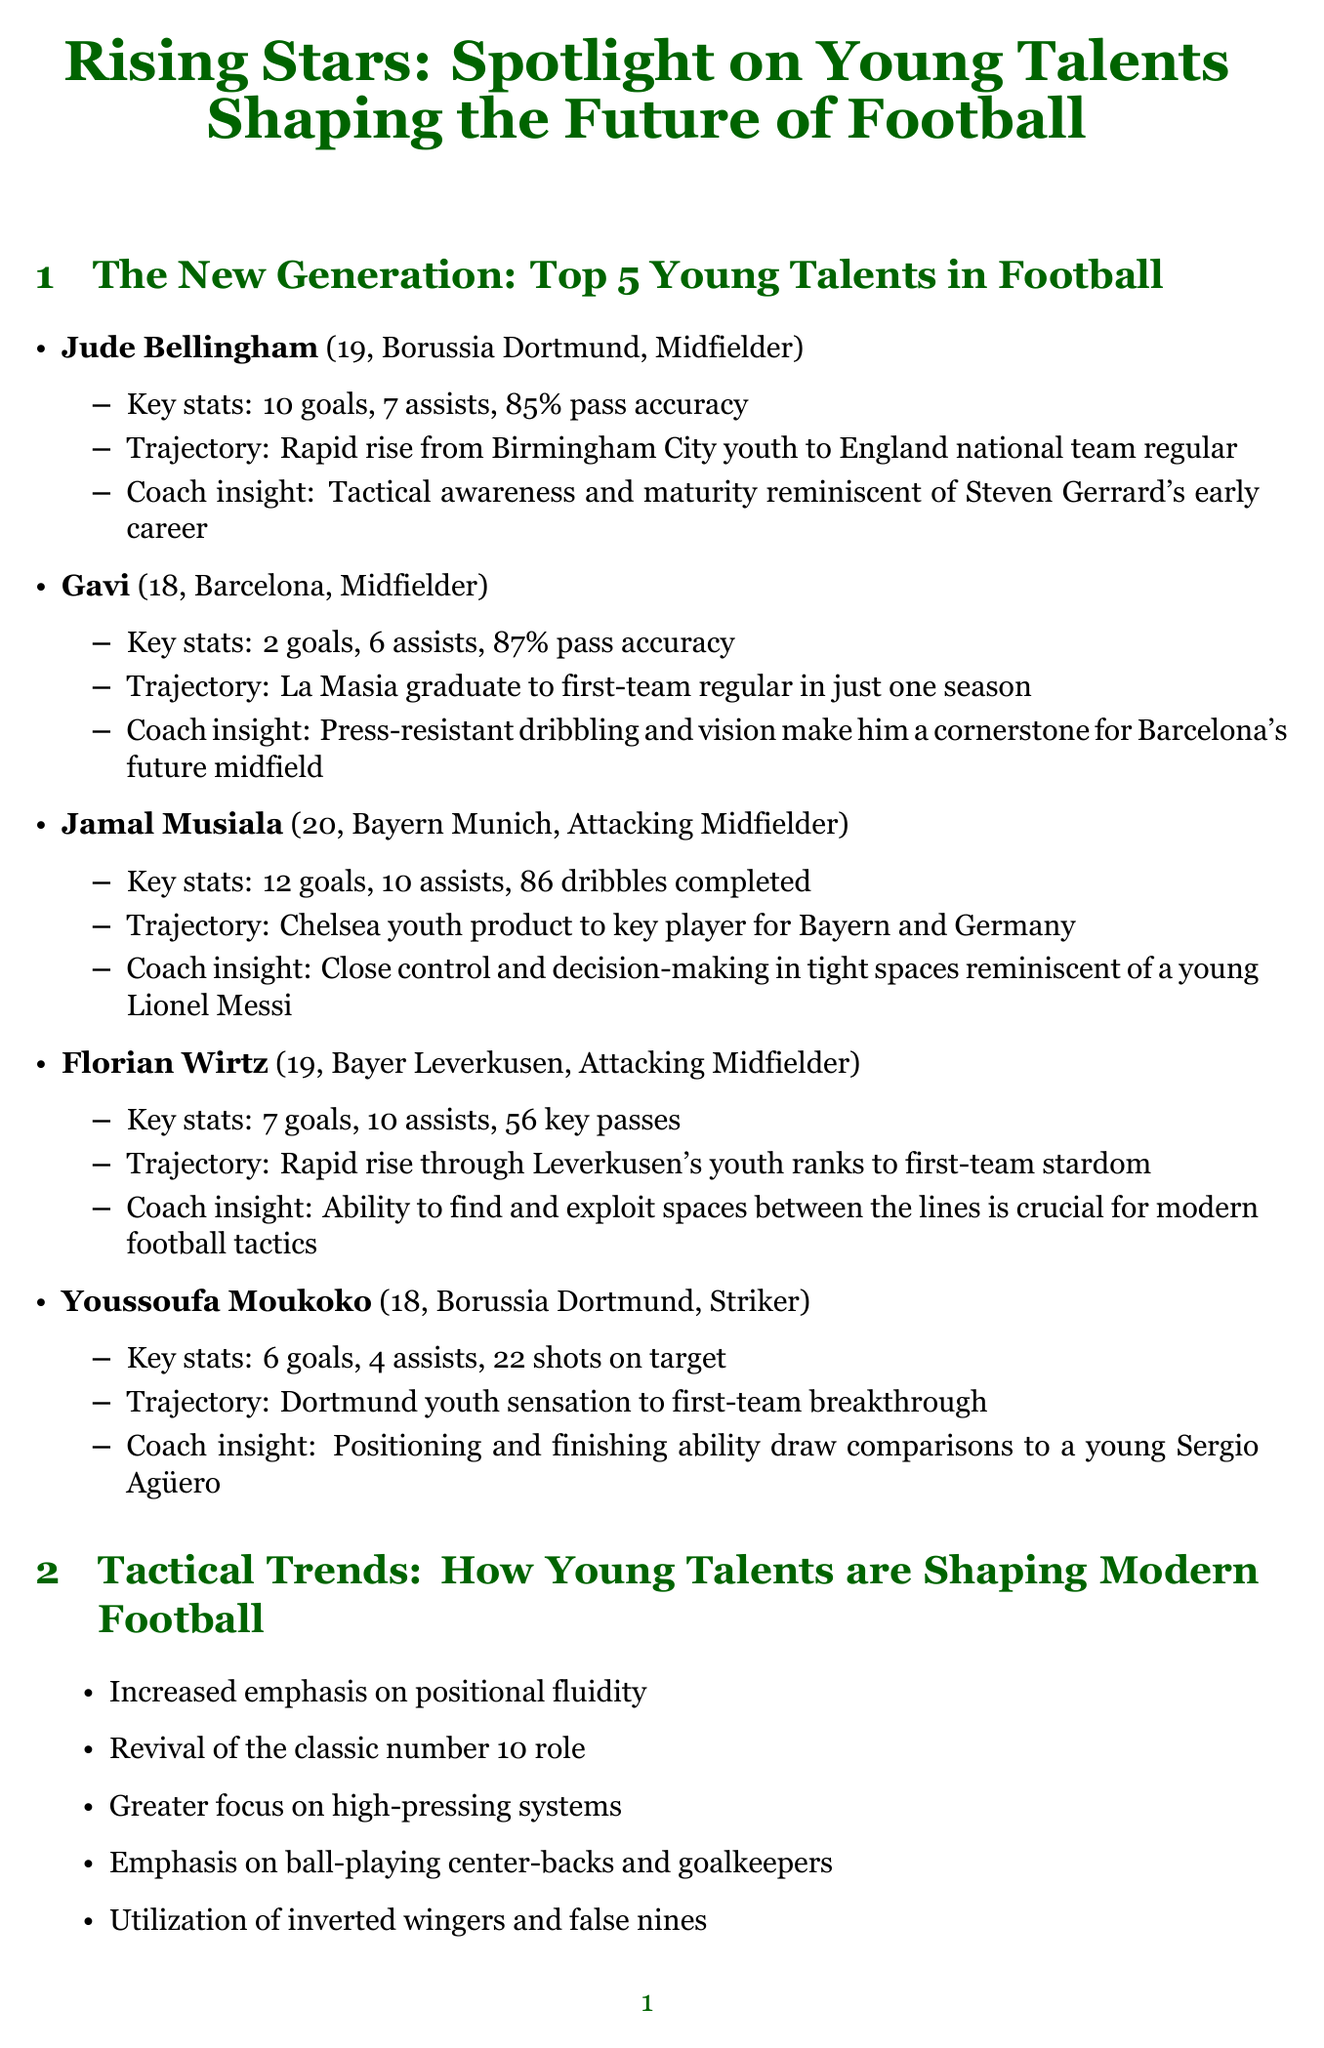What is Jude Bellingham's age? Jude Bellingham is listed with his age in the document as 19.
Answer: 19 How many goals did Jamal Musiala score? The document states that Jamal Musiala scored 12 goals.
Answer: 12 Which club is Gavi associated with? Gavi's club is mentioned in the document as Barcelona.
Answer: Barcelona What key principle is emphasized by Ajax Amsterdam in youth development? The document lists "Technical skills prioritized from early age" as a key principle at Ajax Amsterdam.
Answer: Technical skills prioritized from early age What position does Youssoufa Moukoko play? The document indicates that Youssoufa Moukoko plays as a striker.
Answer: Striker Which player is compared to a young Lionel Messi? The document indicates that Jamal Musiala's qualities are reminiscent of a young Lionel Messi.
Answer: Jamal Musiala What is one challenge in nurturing young talent? The document mentions "Balancing education with football development" as a challenge in nurturing young talent.
Answer: Balancing education with football development What does the document say about Borussia Dortmund's approach to youth development? The document states that Borussia Dortmund has a "Clear pathway to first team" as part of their youth development principles.
Answer: Clear pathway to first team What tactical trend is emphasized regarding high-pressing systems? The document mentions an "Increased emphasis on positional fluidity" as a tactical trend associated with young talents.
Answer: Increased emphasis on positional fluidity 